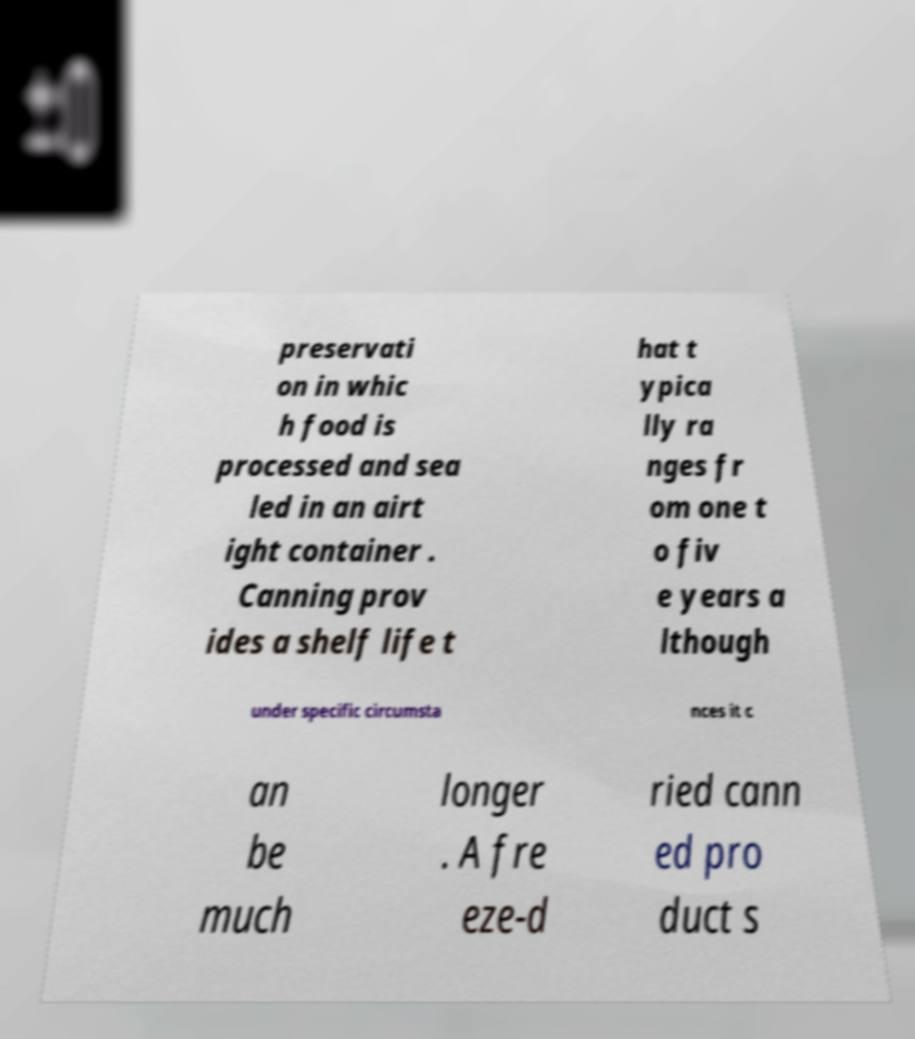For documentation purposes, I need the text within this image transcribed. Could you provide that? preservati on in whic h food is processed and sea led in an airt ight container . Canning prov ides a shelf life t hat t ypica lly ra nges fr om one t o fiv e years a lthough under specific circumsta nces it c an be much longer . A fre eze-d ried cann ed pro duct s 